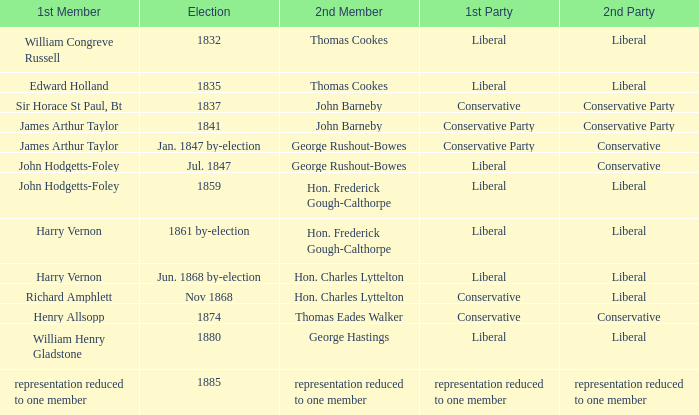What was the 1st Member when the 1st Party had its representation reduced to one member? Representation reduced to one member. 